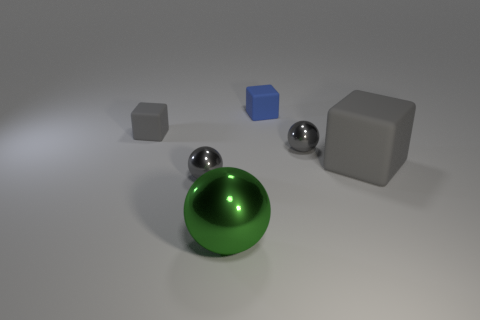What number of other objects are there of the same material as the big gray block?
Keep it short and to the point. 2. Is the number of big shiny things that are in front of the large rubber thing greater than the number of small gray matte blocks that are on the right side of the blue rubber thing?
Make the answer very short. Yes. What is the large object behind the large sphere made of?
Offer a very short reply. Rubber. Does the big gray rubber thing have the same shape as the blue thing?
Offer a terse response. Yes. Are there any other things of the same color as the big sphere?
Give a very brief answer. No. What is the color of the large thing that is the same shape as the tiny blue object?
Provide a short and direct response. Gray. Are there more rubber blocks that are in front of the tiny gray rubber block than small brown rubber blocks?
Provide a short and direct response. Yes. What color is the tiny metallic sphere that is right of the tiny blue thing?
Keep it short and to the point. Gray. The blue block is what size?
Offer a terse response. Small. Are there more gray rubber cubes than small blue blocks?
Your answer should be compact. Yes. 